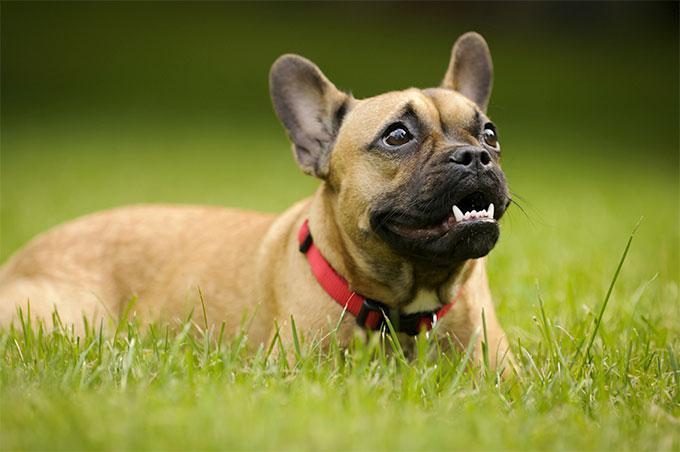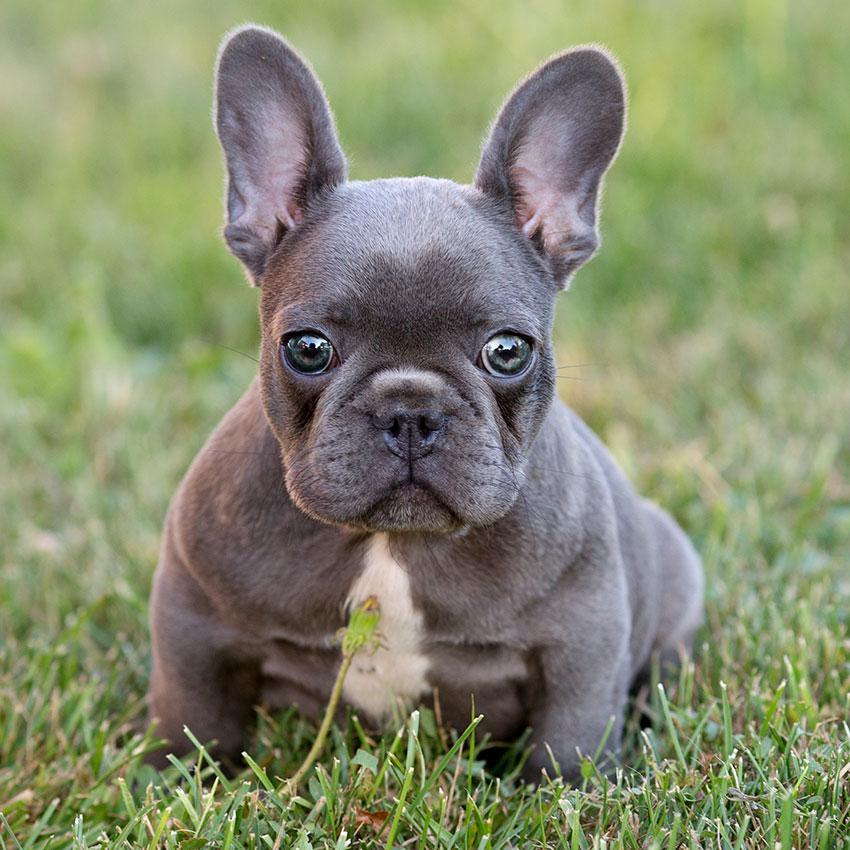The first image is the image on the left, the second image is the image on the right. Evaluate the accuracy of this statement regarding the images: "Left image shows one tan-colored dog posed in the grass, with body turned rightward.". Is it true? Answer yes or no. Yes. The first image is the image on the left, the second image is the image on the right. Assess this claim about the two images: "There is a bulldog with a small white patch of fur on his chest and all four of his feet are in the grass.". Correct or not? Answer yes or no. Yes. 